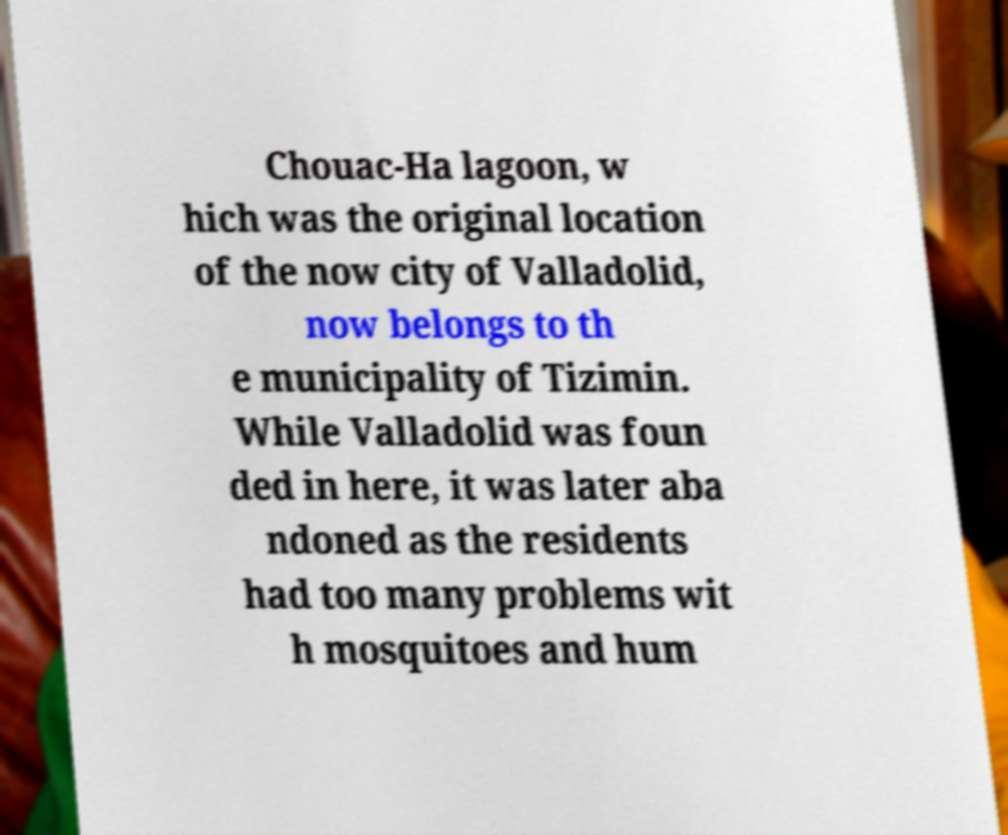Please read and relay the text visible in this image. What does it say? Chouac-Ha lagoon, w hich was the original location of the now city of Valladolid, now belongs to th e municipality of Tizimin. While Valladolid was foun ded in here, it was later aba ndoned as the residents had too many problems wit h mosquitoes and hum 